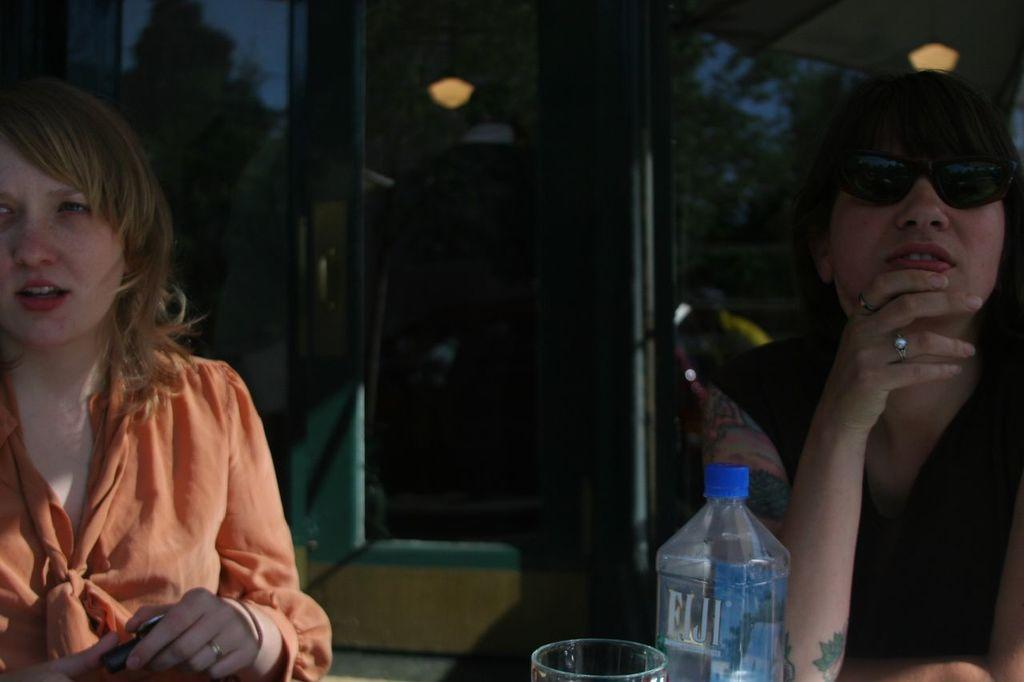How many women are in the image? There are two women in the image. What are the women doing in the image? The women are sitting on chairs. What object can be seen in the image besides the women? There is a bottle glass in the image. What can be seen in the background of the image? There are lights and trees in the background of the image. What type of grape is being used to soothe the woman's throat in the image? There is no grape or reference to a throat in the image; it features two women sitting on chairs and a bottle glass. 